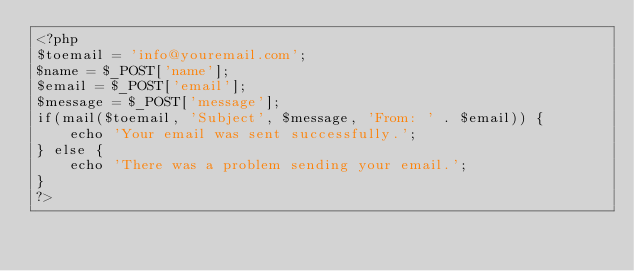Convert code to text. <code><loc_0><loc_0><loc_500><loc_500><_PHP_><?php 
$toemail = 'info@youremail.com';
$name = $_POST['name'];
$email = $_POST['email'];
$message = $_POST['message'];
if(mail($toemail, 'Subject', $message, 'From: ' . $email)) {
	echo 'Your email was sent successfully.';
} else {
	echo 'There was a problem sending your email.';
}
?></code> 